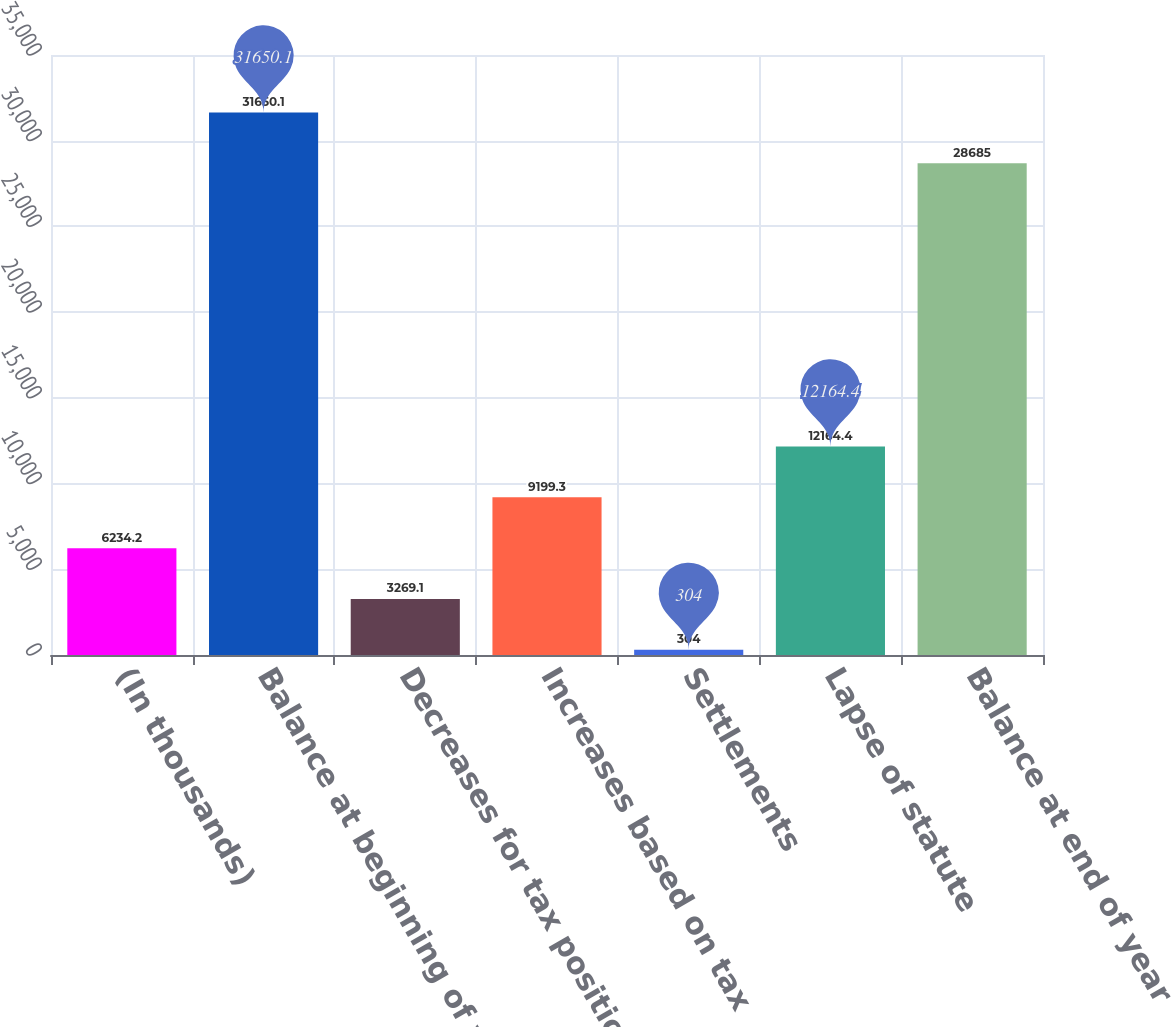Convert chart to OTSL. <chart><loc_0><loc_0><loc_500><loc_500><bar_chart><fcel>(In thousands)<fcel>Balance at beginning of year<fcel>Decreases for tax positions of<fcel>Increases based on tax<fcel>Settlements<fcel>Lapse of statute<fcel>Balance at end of year<nl><fcel>6234.2<fcel>31650.1<fcel>3269.1<fcel>9199.3<fcel>304<fcel>12164.4<fcel>28685<nl></chart> 